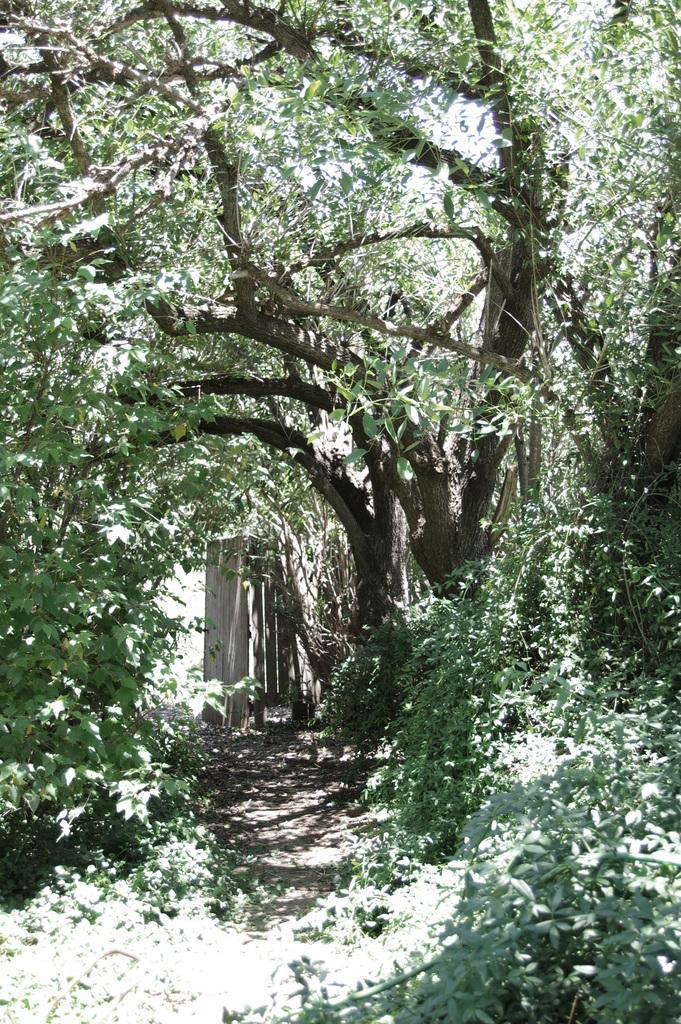Describe this image in one or two sentences. In this image I can see a path in the center and on the both sides of the path I can see number of trees. 